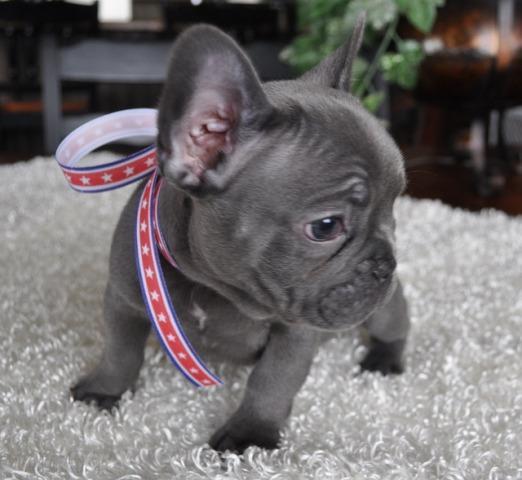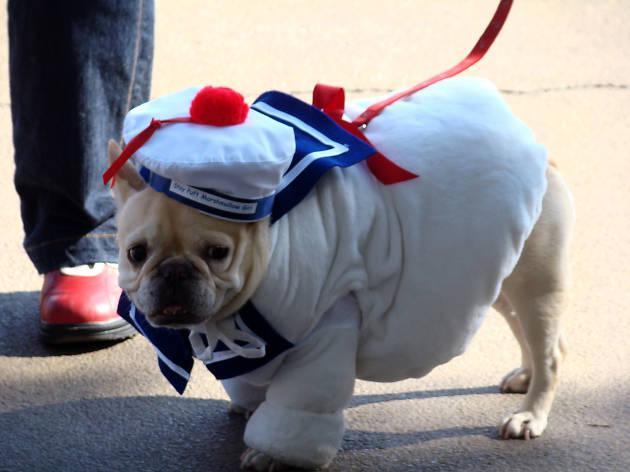The first image is the image on the left, the second image is the image on the right. Given the left and right images, does the statement "There are at most two dogs." hold true? Answer yes or no. Yes. The first image is the image on the left, the second image is the image on the right. Evaluate the accuracy of this statement regarding the images: "Both dogs are standing on all four feet.". Is it true? Answer yes or no. Yes. 